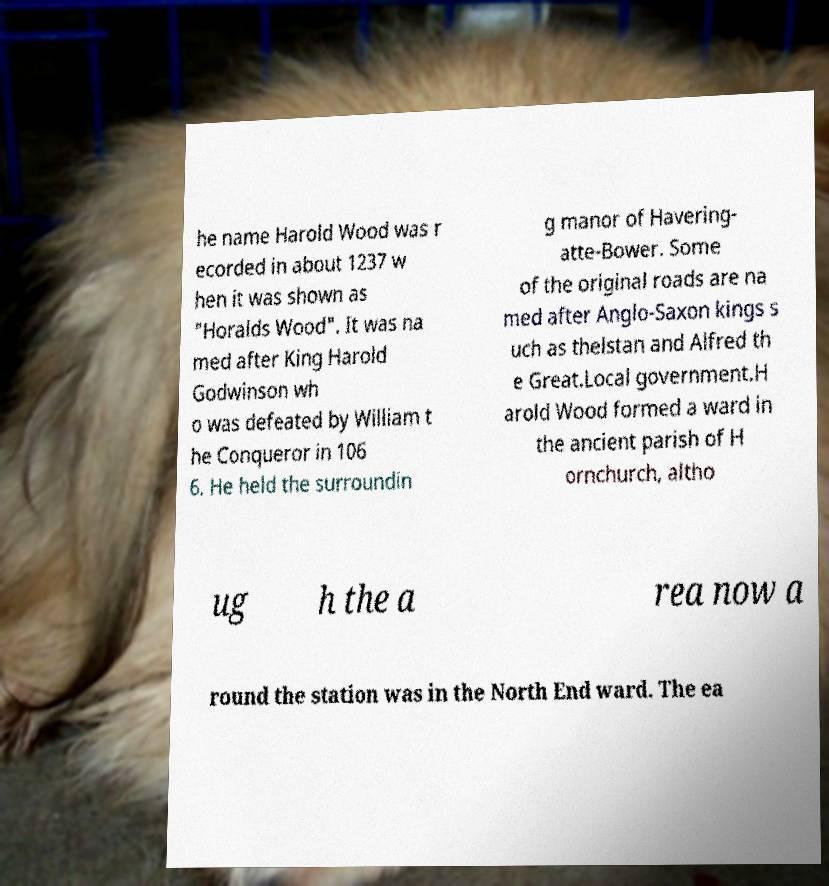There's text embedded in this image that I need extracted. Can you transcribe it verbatim? he name Harold Wood was r ecorded in about 1237 w hen it was shown as "Horalds Wood". It was na med after King Harold Godwinson wh o was defeated by William t he Conqueror in 106 6. He held the surroundin g manor of Havering- atte-Bower. Some of the original roads are na med after Anglo-Saxon kings s uch as thelstan and Alfred th e Great.Local government.H arold Wood formed a ward in the ancient parish of H ornchurch, altho ug h the a rea now a round the station was in the North End ward. The ea 